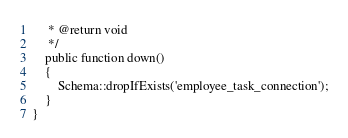Convert code to text. <code><loc_0><loc_0><loc_500><loc_500><_PHP_>     * @return void
     */
    public function down()
    {
        Schema::dropIfExists('employee_task_connection');
    }
}
</code> 